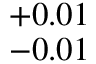<formula> <loc_0><loc_0><loc_500><loc_500>_ { - 0 . 0 1 } ^ { + 0 . 0 1 }</formula> 